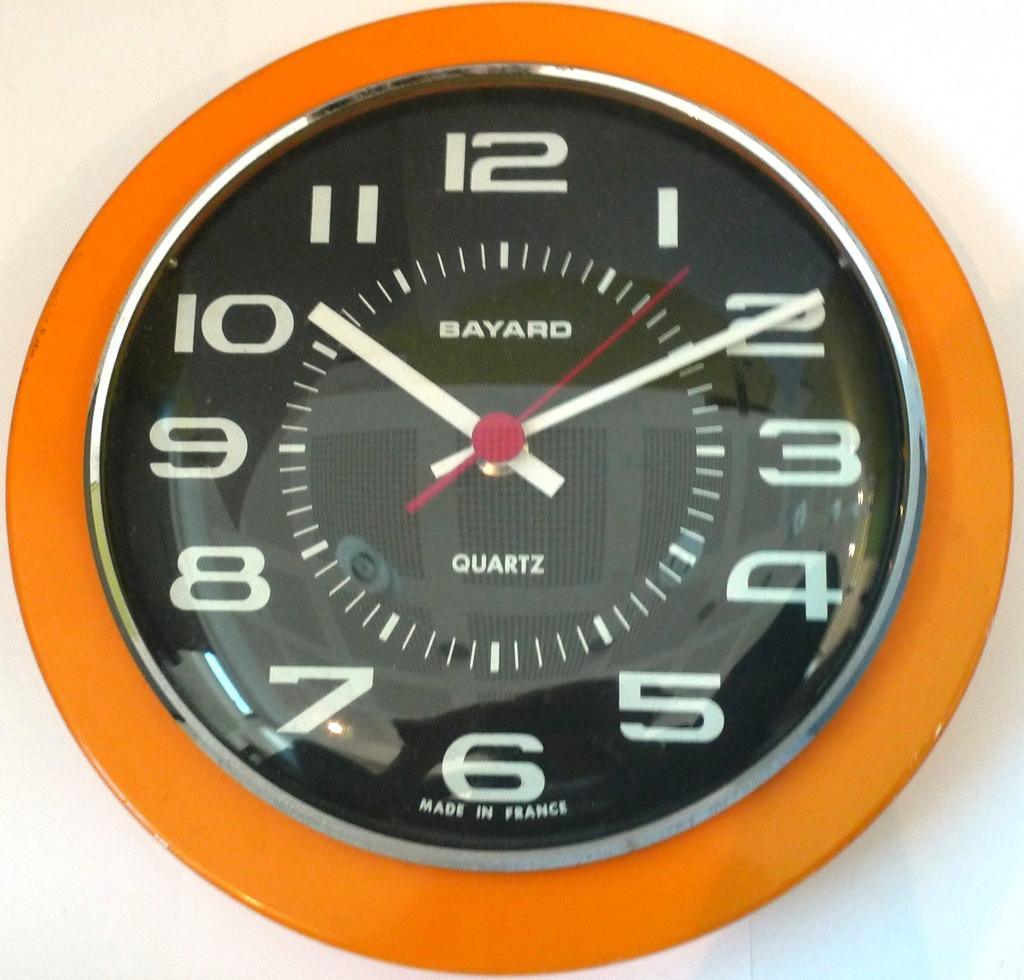<image>
Present a compact description of the photo's key features. a clock that is orange with 1 to 12 